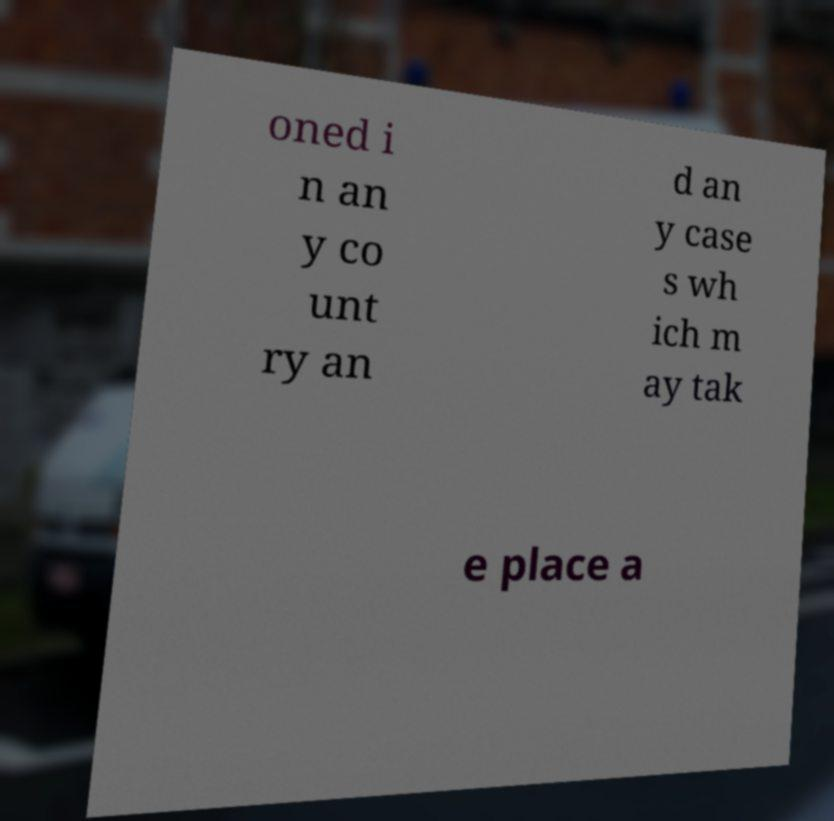For documentation purposes, I need the text within this image transcribed. Could you provide that? oned i n an y co unt ry an d an y case s wh ich m ay tak e place a 